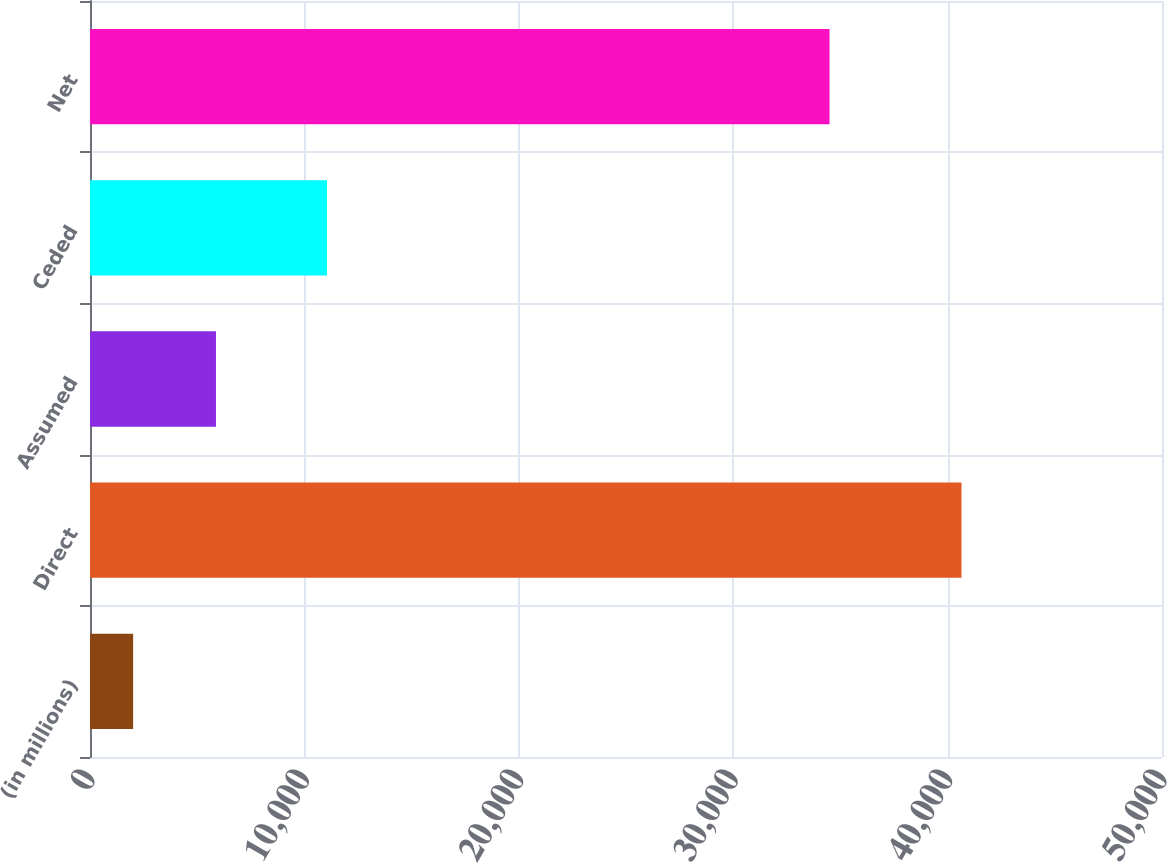Convert chart. <chart><loc_0><loc_0><loc_500><loc_500><bar_chart><fcel>(in millions)<fcel>Direct<fcel>Assumed<fcel>Ceded<fcel>Net<nl><fcel>2012<fcel>40647<fcel>5875.5<fcel>11054<fcel>34493<nl></chart> 